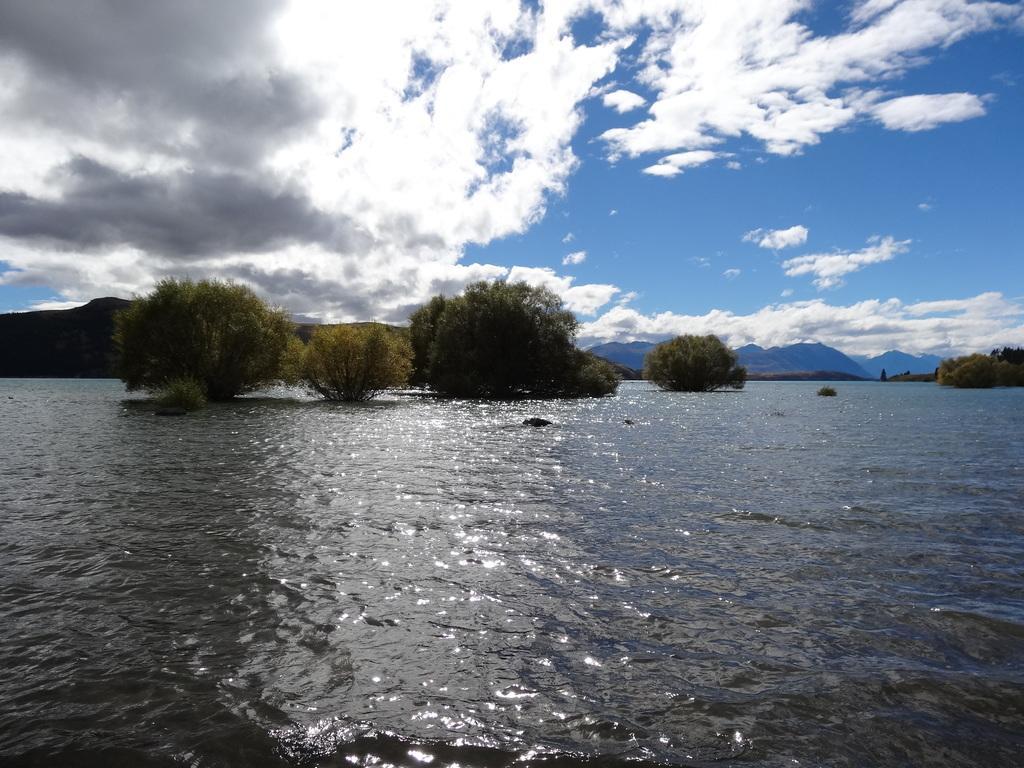Please provide a concise description of this image. In this image there is water. In the back there are trees. In the background there are hills and sky with clouds. 